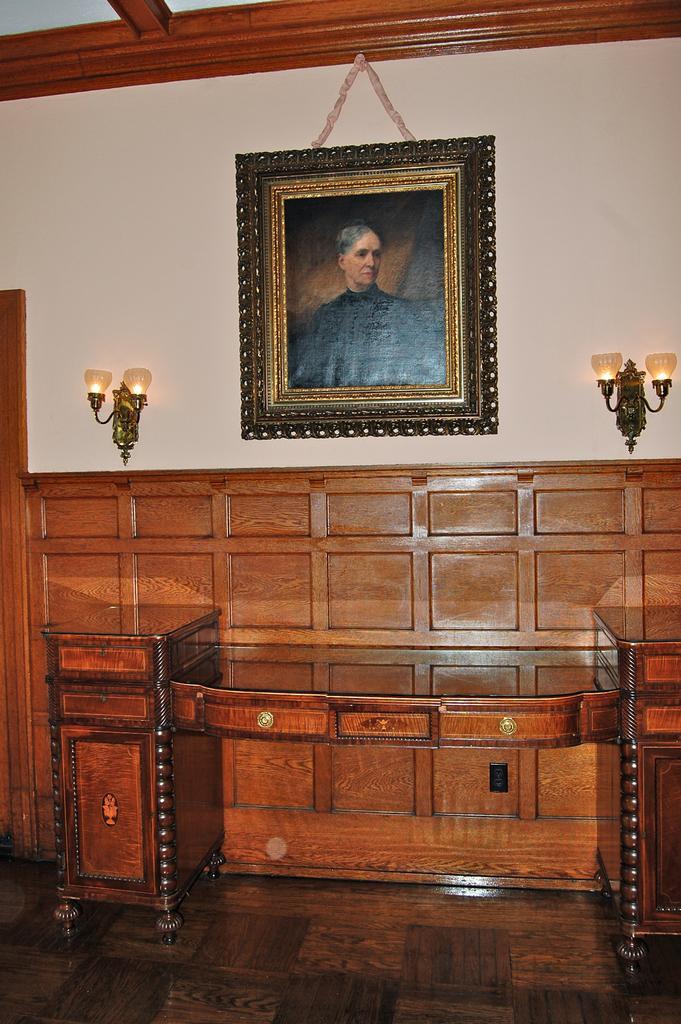Could you give a brief overview of what you see in this image? in the picture there is a wall on the wall there is a frame of a person,beside the wall there is a table on the wall there are lamps. 